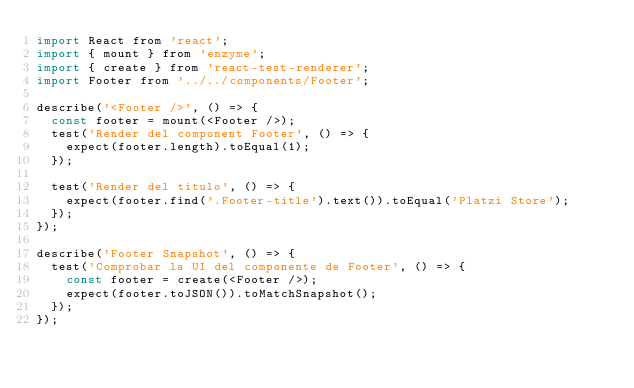Convert code to text. <code><loc_0><loc_0><loc_500><loc_500><_JavaScript_>import React from 'react';
import { mount } from 'enzyme';
import { create } from 'react-test-renderer';
import Footer from '../../components/Footer';

describe('<Footer />', () => {
  const footer = mount(<Footer />);
  test('Render del component Footer', () => {
    expect(footer.length).toEqual(1);
  });

  test('Render del titulo', () => {
    expect(footer.find('.Footer-title').text()).toEqual('Platzi Store');
  });
});

describe('Footer Snapshot', () => {
  test('Comprobar la UI del componente de Footer', () => {
    const footer = create(<Footer />);
    expect(footer.toJSON()).toMatchSnapshot();
  });
});
</code> 